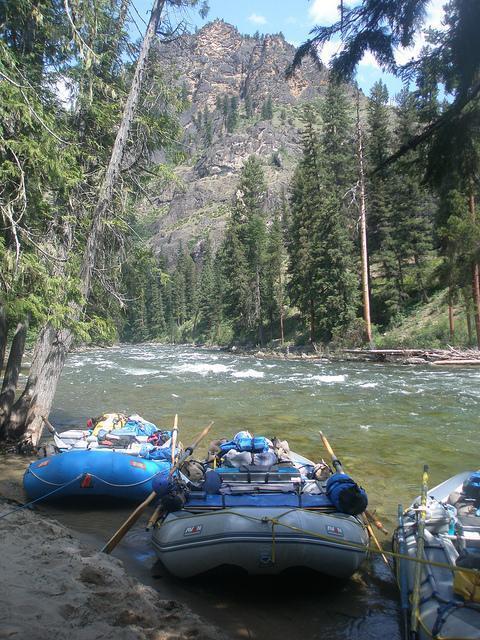How many boats are near the river?
Give a very brief answer. 3. How many boats are about to get in the water?
Give a very brief answer. 3. How many boats are in the photo?
Give a very brief answer. 3. 